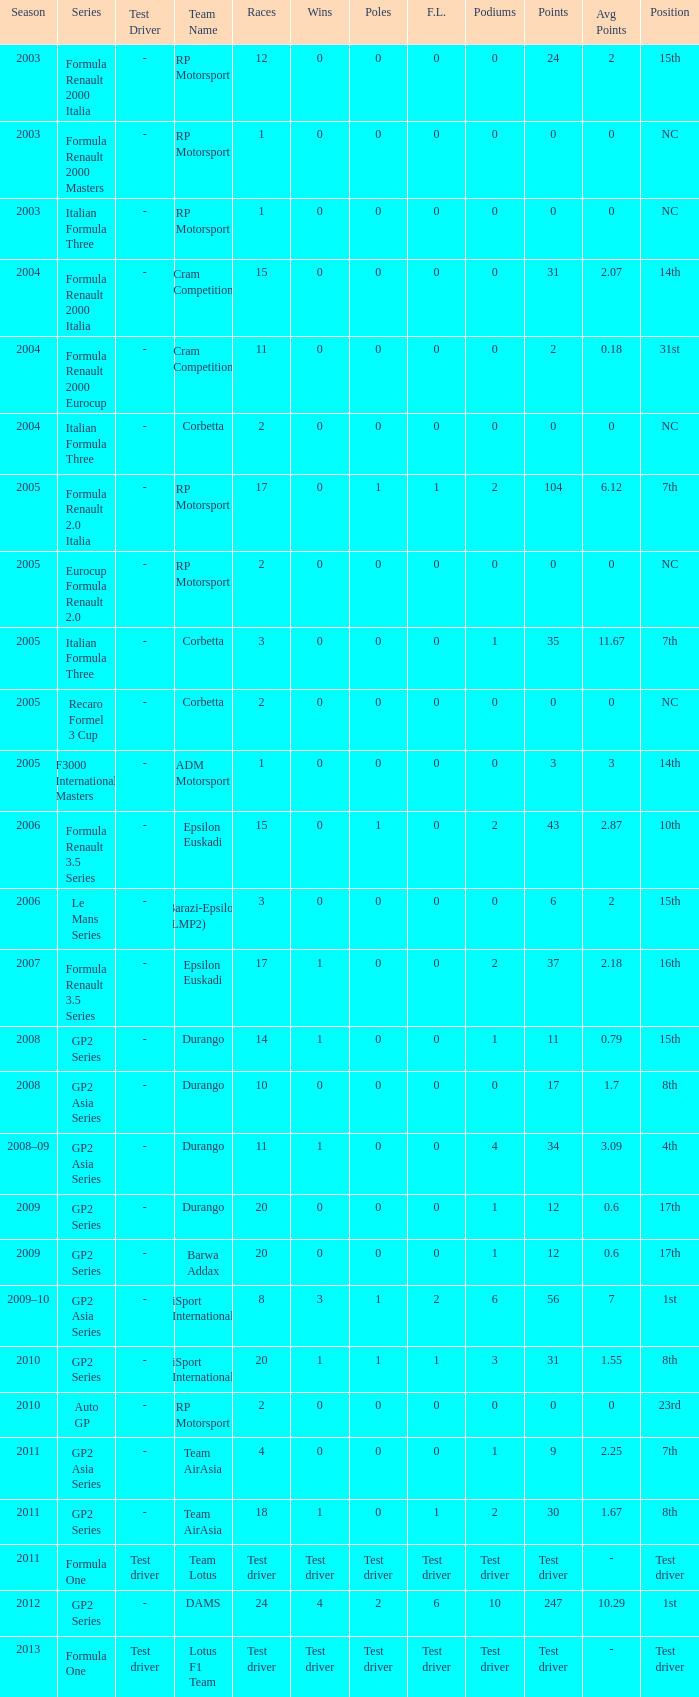What is the number of podiums with 0 wins, 0 F.L. and 35 points? 1.0. 